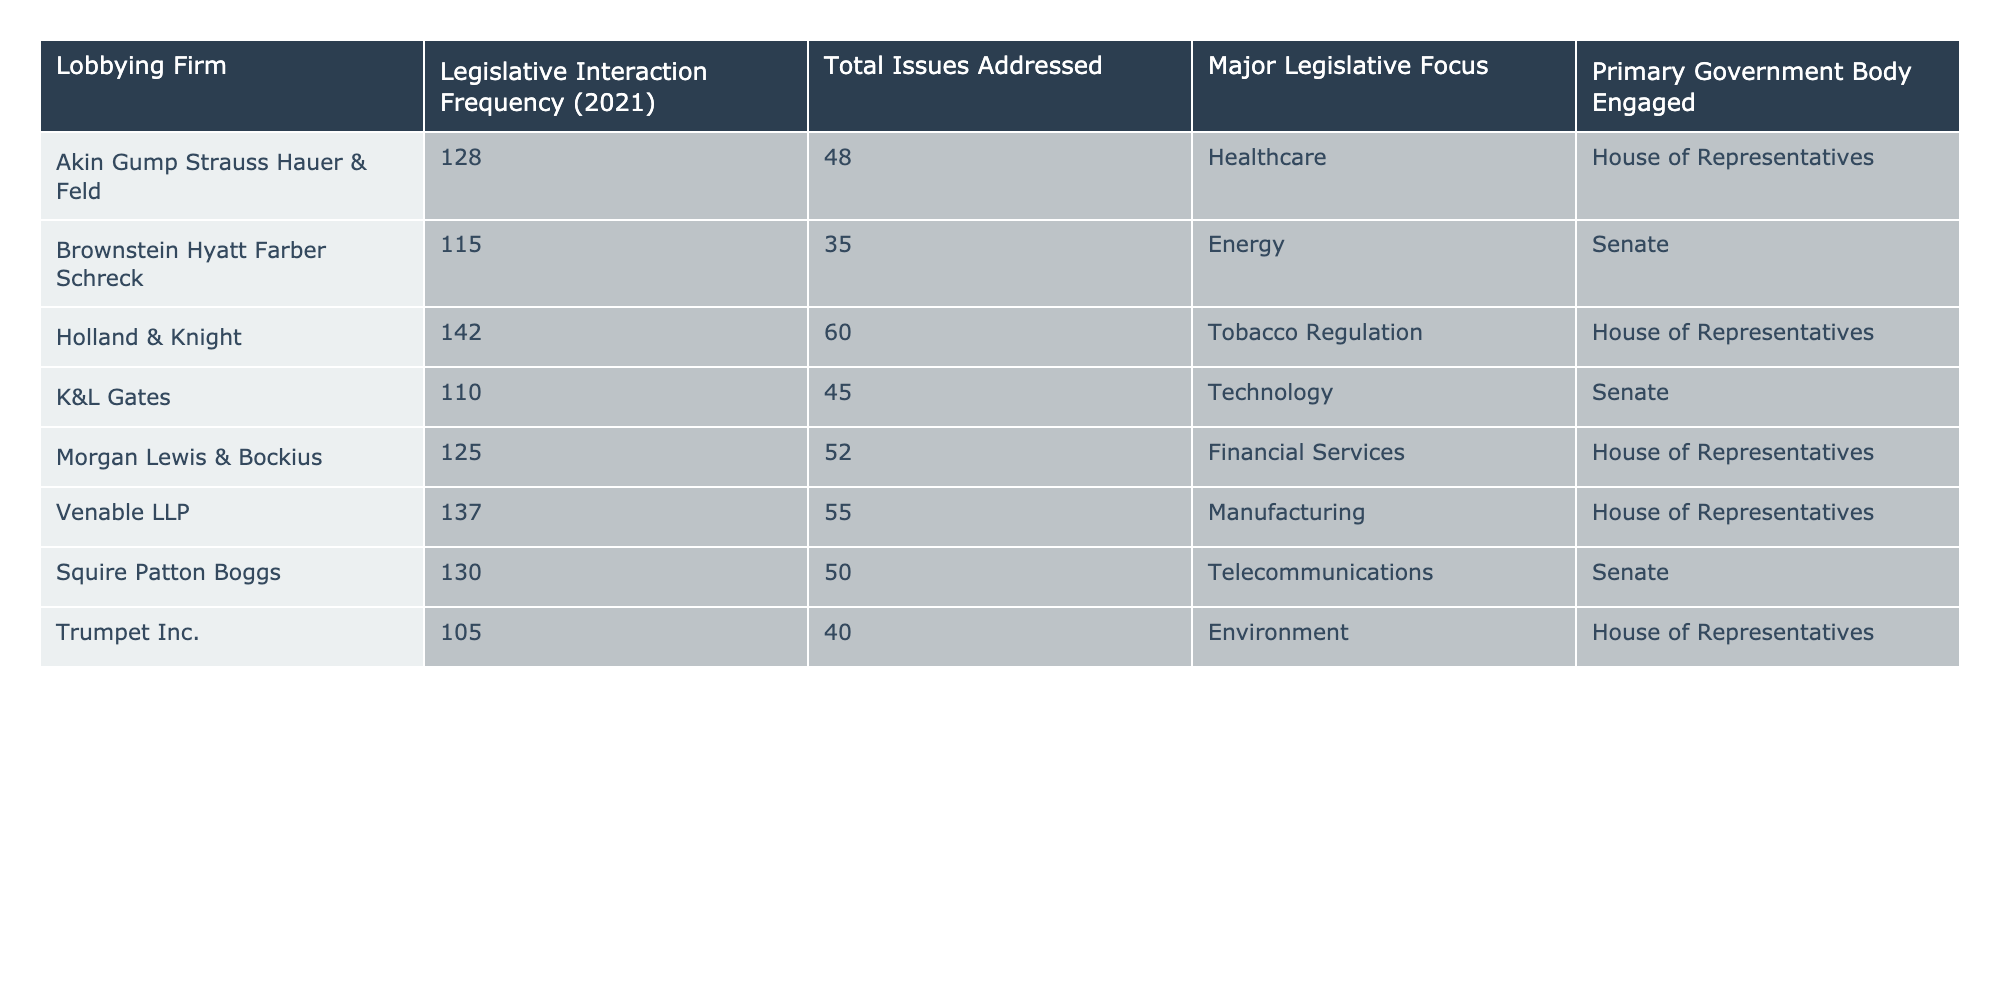What is the total number of legislative interactions for Holland & Knight? According to the table, Holland & Knight has a legislative interaction frequency of 142 in 2021.
Answer: 142 Which lobbying firm addressed the most issues in 2021? Looking at the "Total Issues Addressed" column, Holland & Knight addressed 60 issues, which is the highest among all firms listed.
Answer: Holland & Knight True or False: Trumpet Inc. has a legislative focus on technology. The table shows that Trumpet Inc. has an environmental focus, not technology, so this statement is false.
Answer: False What is the average legislative interaction frequency for the firms listed? To find the average, sum the legislative interaction frequencies: (128 + 115 + 142 + 110 + 125 + 137 + 130 + 105) = 992. There are 8 firms, so the average is 992/8 = 124.
Answer: 124 Which government body is most frequently engaged by the lobbying firms? Analyzing the "Primary Government Body Engaged" column, five firms are engaged with the House of Representatives, while three are engaged with the Senate. Thus, House of Representatives is the most frequently engaged.
Answer: House of Representatives What is the difference in legislative interactions between Akin Gump Strauss Hauer & Feld and K&L Gates? Akin Gump Strauss Hauer & Feld has 128 interactions, while K&L Gates has 110. The difference is calculated as 128 - 110 = 18.
Answer: 18 How many lobbying firms have a major legislative focus on healthcare? From the table, only Akin Gump Strauss Hauer & Feld has a major legislative focus on healthcare; thus, there is one firm with that focus.
Answer: 1 Which firm engaged with the most diverse issues, considering both total issues and legislative interaction frequency? Venable LLP engaged with 55 issues and had a frequency of 137 interactions. Comparing these with others shows that it has a substantial focus. However, Holland & Knight has the highest issue count. Thus, Holland & Knight distinguished with total interactions (142) and engaged with a considerable number of issues (60).
Answer: Holland & Knight Was there any lobbying firm that primarily focused on the Environment according to the table? The table shows that Trumpet Inc. focused on the Environment, confirming that there is a firm with this focus.
Answer: Yes What is the total legislative interaction frequency of firms focusing on healthcare and environmental issues combined? Akin Gump Strauss Hauer & Feld (128 for healthcare) and Trumpet Inc. (105 for environment) add up to a total of 128 + 105 = 233 interactions for both focuses combined.
Answer: 233 